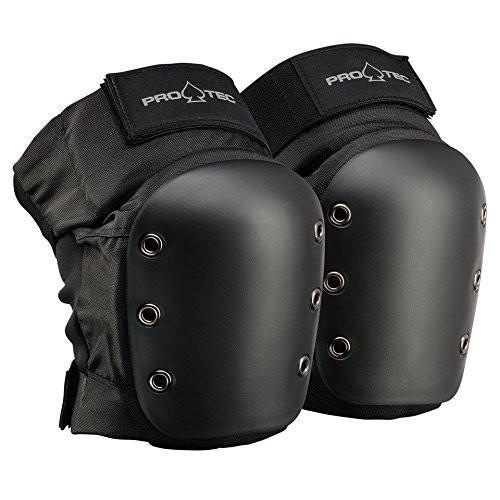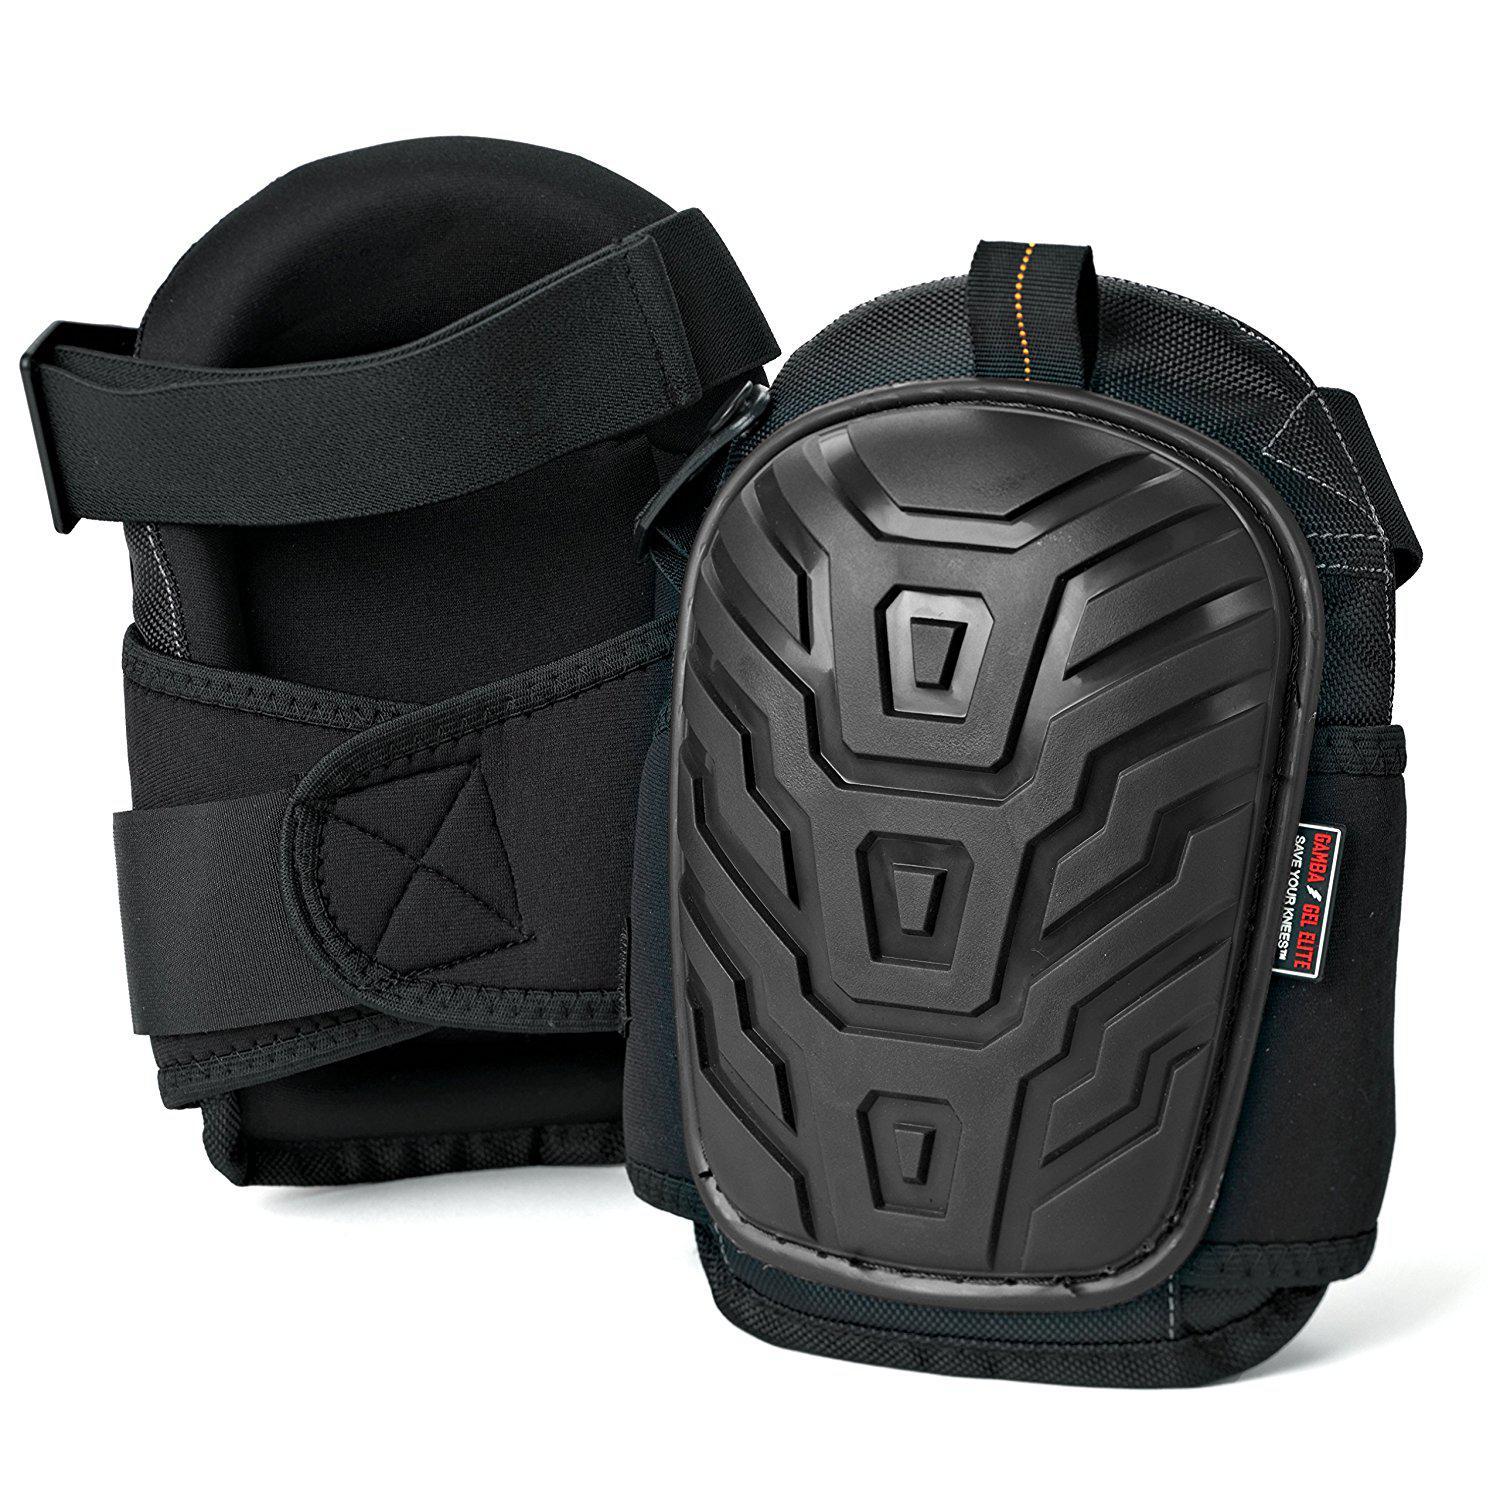The first image is the image on the left, the second image is the image on the right. Considering the images on both sides, is "Left image features one pair of all-black knee pads with three eyelet rivets per side." valid? Answer yes or no. Yes. 